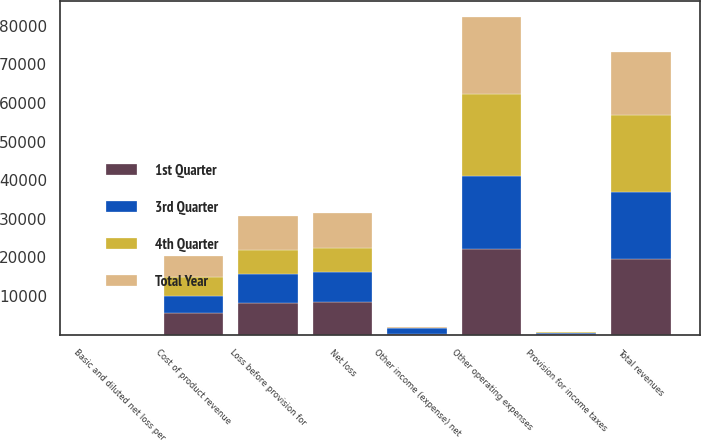Convert chart. <chart><loc_0><loc_0><loc_500><loc_500><stacked_bar_chart><ecel><fcel>Total revenues<fcel>Cost of product revenue<fcel>Other operating expenses<fcel>Other income (expense) net<fcel>Loss before provision for<fcel>Provision for income taxes<fcel>Net loss<fcel>Basic and diluted net loss per<nl><fcel>Total Year<fcel>16357<fcel>5627<fcel>20084<fcel>385<fcel>8969<fcel>145<fcel>9114<fcel>0.28<nl><fcel>4th Quarter<fcel>19999<fcel>4793<fcel>21159<fcel>104<fcel>6057<fcel>273<fcel>6330<fcel>0.18<nl><fcel>3rd Quarter<fcel>17271<fcel>4519<fcel>18792<fcel>1477<fcel>7517<fcel>182<fcel>7699<fcel>0.21<nl><fcel>1st Quarter<fcel>19583<fcel>5498<fcel>22256<fcel>131<fcel>8302<fcel>152<fcel>8454<fcel>0.23<nl></chart> 